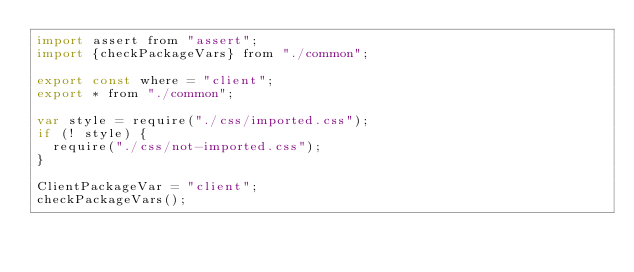Convert code to text. <code><loc_0><loc_0><loc_500><loc_500><_JavaScript_>import assert from "assert";
import {checkPackageVars} from "./common";

export const where = "client";
export * from "./common";

var style = require("./css/imported.css");
if (! style) {
  require("./css/not-imported.css");
}

ClientPackageVar = "client";
checkPackageVars();
</code> 